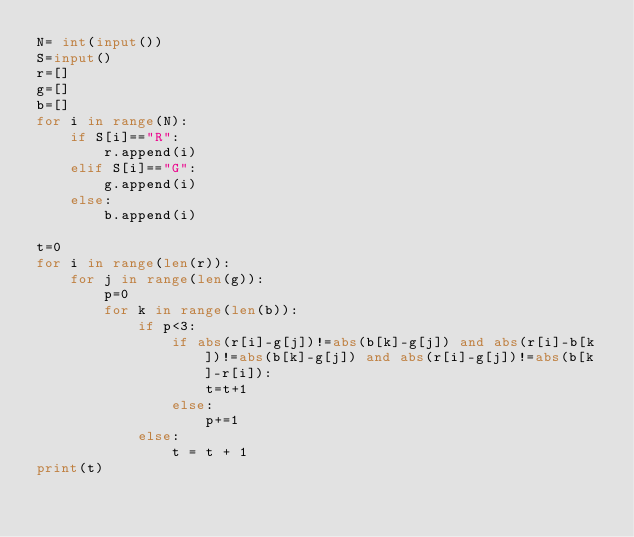<code> <loc_0><loc_0><loc_500><loc_500><_Python_>N= int(input())
S=input()
r=[]
g=[]
b=[]
for i in range(N):
    if S[i]=="R":
        r.append(i)
    elif S[i]=="G":
        g.append(i)
    else:
        b.append(i)

t=0
for i in range(len(r)):
    for j in range(len(g)):
        p=0
        for k in range(len(b)):
            if p<3:
                if abs(r[i]-g[j])!=abs(b[k]-g[j]) and abs(r[i]-b[k])!=abs(b[k]-g[j]) and abs(r[i]-g[j])!=abs(b[k]-r[i]):
                    t=t+1
                else:
                    p+=1
            else:
                t = t + 1
print(t)</code> 